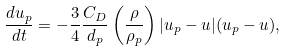Convert formula to latex. <formula><loc_0><loc_0><loc_500><loc_500>\frac { d { u } _ { p } } { d t } = - \frac { 3 } { 4 } \frac { C _ { D } } { d _ { p } } \left ( \frac { \rho } { \rho _ { p } } \right ) | { u } _ { p } - { u } | ( { u } _ { p } - { u } ) ,</formula> 